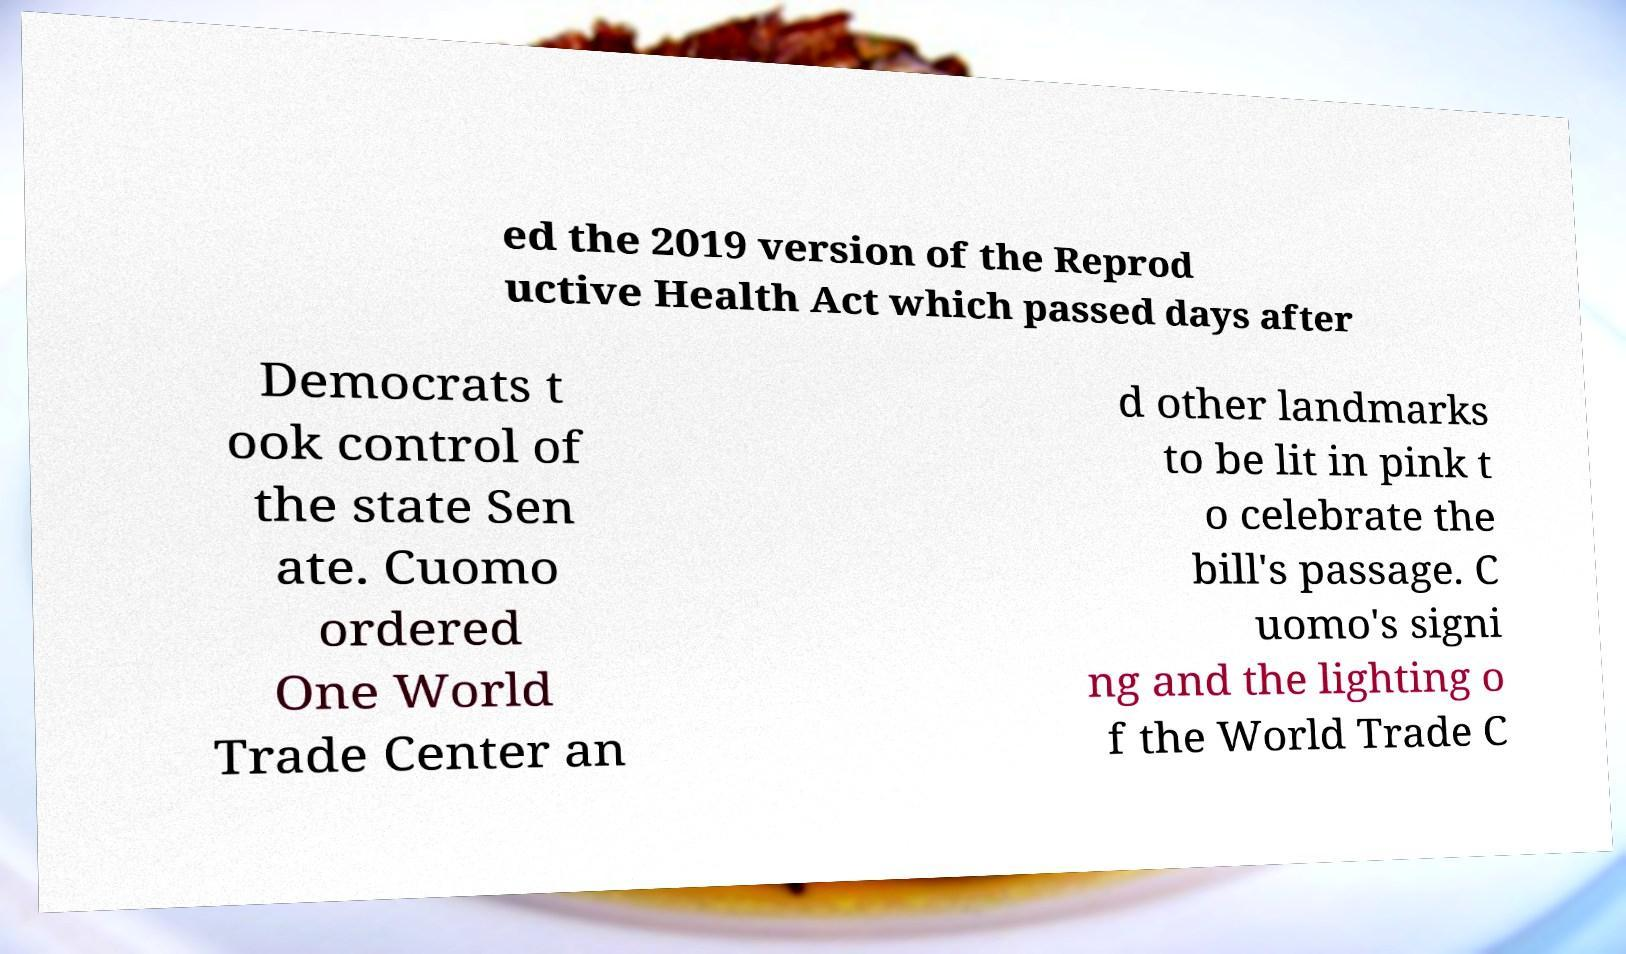Can you read and provide the text displayed in the image?This photo seems to have some interesting text. Can you extract and type it out for me? ed the 2019 version of the Reprod uctive Health Act which passed days after Democrats t ook control of the state Sen ate. Cuomo ordered One World Trade Center an d other landmarks to be lit in pink t o celebrate the bill's passage. C uomo's signi ng and the lighting o f the World Trade C 